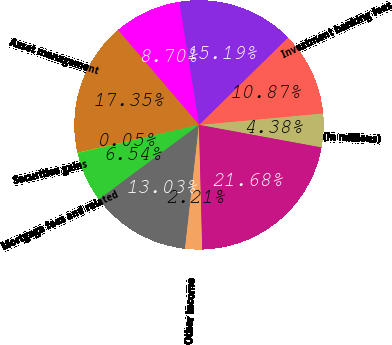<chart> <loc_0><loc_0><loc_500><loc_500><pie_chart><fcel>(in millions)<fcel>Investment banking fees<fcel>Principal transactions<fcel>Lending- and deposit-related<fcel>Asset management<fcel>Securities gains<fcel>Mortgage fees and related<fcel>Credit card income<fcel>Other income<fcel>Noninterest revenue<nl><fcel>4.38%<fcel>10.87%<fcel>15.19%<fcel>8.7%<fcel>17.35%<fcel>0.05%<fcel>6.54%<fcel>13.03%<fcel>2.21%<fcel>21.68%<nl></chart> 